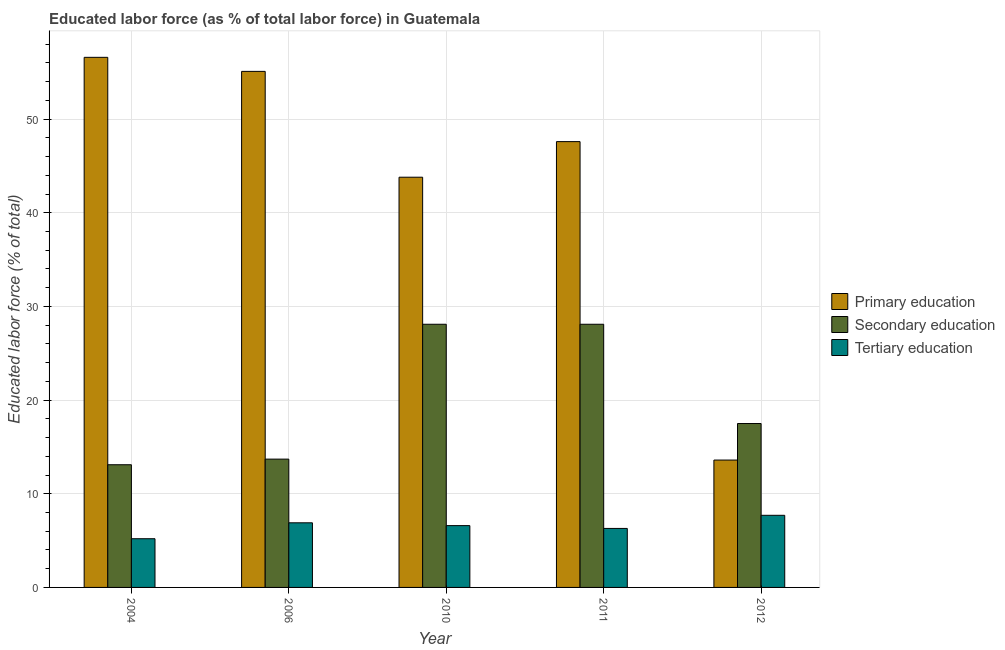Are the number of bars per tick equal to the number of legend labels?
Keep it short and to the point. Yes. Are the number of bars on each tick of the X-axis equal?
Keep it short and to the point. Yes. In how many cases, is the number of bars for a given year not equal to the number of legend labels?
Your response must be concise. 0. What is the percentage of labor force who received primary education in 2010?
Offer a very short reply. 43.8. Across all years, what is the maximum percentage of labor force who received tertiary education?
Keep it short and to the point. 7.7. Across all years, what is the minimum percentage of labor force who received primary education?
Your response must be concise. 13.6. In which year was the percentage of labor force who received tertiary education minimum?
Provide a succinct answer. 2004. What is the total percentage of labor force who received tertiary education in the graph?
Offer a terse response. 32.7. What is the difference between the percentage of labor force who received secondary education in 2006 and that in 2011?
Provide a short and direct response. -14.4. What is the difference between the percentage of labor force who received secondary education in 2011 and the percentage of labor force who received primary education in 2012?
Your answer should be very brief. 10.6. What is the average percentage of labor force who received secondary education per year?
Your answer should be very brief. 20.1. In the year 2004, what is the difference between the percentage of labor force who received secondary education and percentage of labor force who received tertiary education?
Your answer should be very brief. 0. In how many years, is the percentage of labor force who received secondary education greater than 20 %?
Offer a terse response. 2. What is the ratio of the percentage of labor force who received primary education in 2006 to that in 2010?
Offer a terse response. 1.26. What is the difference between the highest and the lowest percentage of labor force who received secondary education?
Ensure brevity in your answer.  15. Is the sum of the percentage of labor force who received primary education in 2004 and 2011 greater than the maximum percentage of labor force who received secondary education across all years?
Ensure brevity in your answer.  Yes. What does the 1st bar from the left in 2006 represents?
Keep it short and to the point. Primary education. What does the 2nd bar from the right in 2004 represents?
Offer a very short reply. Secondary education. Is it the case that in every year, the sum of the percentage of labor force who received primary education and percentage of labor force who received secondary education is greater than the percentage of labor force who received tertiary education?
Your response must be concise. Yes. Does the graph contain grids?
Offer a very short reply. Yes. Where does the legend appear in the graph?
Your answer should be compact. Center right. How many legend labels are there?
Offer a very short reply. 3. How are the legend labels stacked?
Your response must be concise. Vertical. What is the title of the graph?
Provide a short and direct response. Educated labor force (as % of total labor force) in Guatemala. What is the label or title of the Y-axis?
Provide a short and direct response. Educated labor force (% of total). What is the Educated labor force (% of total) in Primary education in 2004?
Your answer should be compact. 56.6. What is the Educated labor force (% of total) in Secondary education in 2004?
Offer a very short reply. 13.1. What is the Educated labor force (% of total) in Tertiary education in 2004?
Provide a short and direct response. 5.2. What is the Educated labor force (% of total) in Primary education in 2006?
Ensure brevity in your answer.  55.1. What is the Educated labor force (% of total) of Secondary education in 2006?
Make the answer very short. 13.7. What is the Educated labor force (% of total) of Tertiary education in 2006?
Make the answer very short. 6.9. What is the Educated labor force (% of total) in Primary education in 2010?
Ensure brevity in your answer.  43.8. What is the Educated labor force (% of total) of Secondary education in 2010?
Give a very brief answer. 28.1. What is the Educated labor force (% of total) in Tertiary education in 2010?
Offer a terse response. 6.6. What is the Educated labor force (% of total) of Primary education in 2011?
Make the answer very short. 47.6. What is the Educated labor force (% of total) in Secondary education in 2011?
Your response must be concise. 28.1. What is the Educated labor force (% of total) of Tertiary education in 2011?
Your answer should be compact. 6.3. What is the Educated labor force (% of total) in Primary education in 2012?
Make the answer very short. 13.6. What is the Educated labor force (% of total) of Secondary education in 2012?
Offer a terse response. 17.5. What is the Educated labor force (% of total) in Tertiary education in 2012?
Provide a succinct answer. 7.7. Across all years, what is the maximum Educated labor force (% of total) of Primary education?
Provide a short and direct response. 56.6. Across all years, what is the maximum Educated labor force (% of total) in Secondary education?
Keep it short and to the point. 28.1. Across all years, what is the maximum Educated labor force (% of total) in Tertiary education?
Provide a succinct answer. 7.7. Across all years, what is the minimum Educated labor force (% of total) of Primary education?
Offer a very short reply. 13.6. Across all years, what is the minimum Educated labor force (% of total) of Secondary education?
Provide a succinct answer. 13.1. Across all years, what is the minimum Educated labor force (% of total) in Tertiary education?
Your response must be concise. 5.2. What is the total Educated labor force (% of total) of Primary education in the graph?
Make the answer very short. 216.7. What is the total Educated labor force (% of total) of Secondary education in the graph?
Offer a very short reply. 100.5. What is the total Educated labor force (% of total) in Tertiary education in the graph?
Provide a succinct answer. 32.7. What is the difference between the Educated labor force (% of total) of Primary education in 2004 and that in 2006?
Your answer should be very brief. 1.5. What is the difference between the Educated labor force (% of total) of Secondary education in 2004 and that in 2010?
Make the answer very short. -15. What is the difference between the Educated labor force (% of total) in Tertiary education in 2004 and that in 2010?
Provide a short and direct response. -1.4. What is the difference between the Educated labor force (% of total) of Primary education in 2004 and that in 2011?
Offer a terse response. 9. What is the difference between the Educated labor force (% of total) in Secondary education in 2004 and that in 2011?
Your answer should be very brief. -15. What is the difference between the Educated labor force (% of total) in Tertiary education in 2004 and that in 2011?
Provide a short and direct response. -1.1. What is the difference between the Educated labor force (% of total) in Secondary education in 2004 and that in 2012?
Provide a short and direct response. -4.4. What is the difference between the Educated labor force (% of total) of Tertiary education in 2004 and that in 2012?
Keep it short and to the point. -2.5. What is the difference between the Educated labor force (% of total) of Secondary education in 2006 and that in 2010?
Keep it short and to the point. -14.4. What is the difference between the Educated labor force (% of total) of Tertiary education in 2006 and that in 2010?
Provide a succinct answer. 0.3. What is the difference between the Educated labor force (% of total) of Secondary education in 2006 and that in 2011?
Provide a short and direct response. -14.4. What is the difference between the Educated labor force (% of total) of Primary education in 2006 and that in 2012?
Ensure brevity in your answer.  41.5. What is the difference between the Educated labor force (% of total) of Secondary education in 2006 and that in 2012?
Your answer should be very brief. -3.8. What is the difference between the Educated labor force (% of total) in Tertiary education in 2006 and that in 2012?
Keep it short and to the point. -0.8. What is the difference between the Educated labor force (% of total) in Primary education in 2010 and that in 2011?
Offer a very short reply. -3.8. What is the difference between the Educated labor force (% of total) in Secondary education in 2010 and that in 2011?
Offer a very short reply. 0. What is the difference between the Educated labor force (% of total) of Primary education in 2010 and that in 2012?
Keep it short and to the point. 30.2. What is the difference between the Educated labor force (% of total) in Secondary education in 2010 and that in 2012?
Give a very brief answer. 10.6. What is the difference between the Educated labor force (% of total) in Tertiary education in 2010 and that in 2012?
Offer a very short reply. -1.1. What is the difference between the Educated labor force (% of total) of Tertiary education in 2011 and that in 2012?
Your answer should be compact. -1.4. What is the difference between the Educated labor force (% of total) in Primary education in 2004 and the Educated labor force (% of total) in Secondary education in 2006?
Your answer should be compact. 42.9. What is the difference between the Educated labor force (% of total) of Primary education in 2004 and the Educated labor force (% of total) of Tertiary education in 2006?
Provide a short and direct response. 49.7. What is the difference between the Educated labor force (% of total) of Secondary education in 2004 and the Educated labor force (% of total) of Tertiary education in 2006?
Your response must be concise. 6.2. What is the difference between the Educated labor force (% of total) of Primary education in 2004 and the Educated labor force (% of total) of Tertiary education in 2010?
Your answer should be very brief. 50. What is the difference between the Educated labor force (% of total) of Primary education in 2004 and the Educated labor force (% of total) of Tertiary education in 2011?
Your response must be concise. 50.3. What is the difference between the Educated labor force (% of total) in Primary education in 2004 and the Educated labor force (% of total) in Secondary education in 2012?
Provide a succinct answer. 39.1. What is the difference between the Educated labor force (% of total) in Primary education in 2004 and the Educated labor force (% of total) in Tertiary education in 2012?
Ensure brevity in your answer.  48.9. What is the difference between the Educated labor force (% of total) in Secondary education in 2004 and the Educated labor force (% of total) in Tertiary education in 2012?
Make the answer very short. 5.4. What is the difference between the Educated labor force (% of total) of Primary education in 2006 and the Educated labor force (% of total) of Secondary education in 2010?
Ensure brevity in your answer.  27. What is the difference between the Educated labor force (% of total) in Primary education in 2006 and the Educated labor force (% of total) in Tertiary education in 2010?
Your response must be concise. 48.5. What is the difference between the Educated labor force (% of total) in Secondary education in 2006 and the Educated labor force (% of total) in Tertiary education in 2010?
Offer a terse response. 7.1. What is the difference between the Educated labor force (% of total) in Primary education in 2006 and the Educated labor force (% of total) in Secondary education in 2011?
Provide a short and direct response. 27. What is the difference between the Educated labor force (% of total) in Primary education in 2006 and the Educated labor force (% of total) in Tertiary education in 2011?
Offer a very short reply. 48.8. What is the difference between the Educated labor force (% of total) of Secondary education in 2006 and the Educated labor force (% of total) of Tertiary education in 2011?
Keep it short and to the point. 7.4. What is the difference between the Educated labor force (% of total) in Primary education in 2006 and the Educated labor force (% of total) in Secondary education in 2012?
Make the answer very short. 37.6. What is the difference between the Educated labor force (% of total) of Primary education in 2006 and the Educated labor force (% of total) of Tertiary education in 2012?
Provide a short and direct response. 47.4. What is the difference between the Educated labor force (% of total) of Secondary education in 2006 and the Educated labor force (% of total) of Tertiary education in 2012?
Provide a short and direct response. 6. What is the difference between the Educated labor force (% of total) in Primary education in 2010 and the Educated labor force (% of total) in Tertiary education in 2011?
Keep it short and to the point. 37.5. What is the difference between the Educated labor force (% of total) in Secondary education in 2010 and the Educated labor force (% of total) in Tertiary education in 2011?
Your answer should be compact. 21.8. What is the difference between the Educated labor force (% of total) in Primary education in 2010 and the Educated labor force (% of total) in Secondary education in 2012?
Offer a terse response. 26.3. What is the difference between the Educated labor force (% of total) in Primary education in 2010 and the Educated labor force (% of total) in Tertiary education in 2012?
Offer a terse response. 36.1. What is the difference between the Educated labor force (% of total) in Secondary education in 2010 and the Educated labor force (% of total) in Tertiary education in 2012?
Your response must be concise. 20.4. What is the difference between the Educated labor force (% of total) in Primary education in 2011 and the Educated labor force (% of total) in Secondary education in 2012?
Ensure brevity in your answer.  30.1. What is the difference between the Educated labor force (% of total) in Primary education in 2011 and the Educated labor force (% of total) in Tertiary education in 2012?
Your response must be concise. 39.9. What is the difference between the Educated labor force (% of total) of Secondary education in 2011 and the Educated labor force (% of total) of Tertiary education in 2012?
Your answer should be very brief. 20.4. What is the average Educated labor force (% of total) of Primary education per year?
Give a very brief answer. 43.34. What is the average Educated labor force (% of total) in Secondary education per year?
Give a very brief answer. 20.1. What is the average Educated labor force (% of total) in Tertiary education per year?
Make the answer very short. 6.54. In the year 2004, what is the difference between the Educated labor force (% of total) in Primary education and Educated labor force (% of total) in Secondary education?
Ensure brevity in your answer.  43.5. In the year 2004, what is the difference between the Educated labor force (% of total) of Primary education and Educated labor force (% of total) of Tertiary education?
Keep it short and to the point. 51.4. In the year 2006, what is the difference between the Educated labor force (% of total) in Primary education and Educated labor force (% of total) in Secondary education?
Offer a very short reply. 41.4. In the year 2006, what is the difference between the Educated labor force (% of total) in Primary education and Educated labor force (% of total) in Tertiary education?
Give a very brief answer. 48.2. In the year 2006, what is the difference between the Educated labor force (% of total) of Secondary education and Educated labor force (% of total) of Tertiary education?
Your answer should be very brief. 6.8. In the year 2010, what is the difference between the Educated labor force (% of total) in Primary education and Educated labor force (% of total) in Tertiary education?
Give a very brief answer. 37.2. In the year 2010, what is the difference between the Educated labor force (% of total) of Secondary education and Educated labor force (% of total) of Tertiary education?
Make the answer very short. 21.5. In the year 2011, what is the difference between the Educated labor force (% of total) of Primary education and Educated labor force (% of total) of Tertiary education?
Offer a terse response. 41.3. In the year 2011, what is the difference between the Educated labor force (% of total) of Secondary education and Educated labor force (% of total) of Tertiary education?
Offer a terse response. 21.8. In the year 2012, what is the difference between the Educated labor force (% of total) of Primary education and Educated labor force (% of total) of Secondary education?
Offer a terse response. -3.9. In the year 2012, what is the difference between the Educated labor force (% of total) in Primary education and Educated labor force (% of total) in Tertiary education?
Keep it short and to the point. 5.9. What is the ratio of the Educated labor force (% of total) of Primary education in 2004 to that in 2006?
Your response must be concise. 1.03. What is the ratio of the Educated labor force (% of total) of Secondary education in 2004 to that in 2006?
Give a very brief answer. 0.96. What is the ratio of the Educated labor force (% of total) in Tertiary education in 2004 to that in 2006?
Give a very brief answer. 0.75. What is the ratio of the Educated labor force (% of total) in Primary education in 2004 to that in 2010?
Your answer should be very brief. 1.29. What is the ratio of the Educated labor force (% of total) of Secondary education in 2004 to that in 2010?
Keep it short and to the point. 0.47. What is the ratio of the Educated labor force (% of total) of Tertiary education in 2004 to that in 2010?
Give a very brief answer. 0.79. What is the ratio of the Educated labor force (% of total) of Primary education in 2004 to that in 2011?
Offer a very short reply. 1.19. What is the ratio of the Educated labor force (% of total) in Secondary education in 2004 to that in 2011?
Your answer should be compact. 0.47. What is the ratio of the Educated labor force (% of total) in Tertiary education in 2004 to that in 2011?
Provide a short and direct response. 0.83. What is the ratio of the Educated labor force (% of total) of Primary education in 2004 to that in 2012?
Keep it short and to the point. 4.16. What is the ratio of the Educated labor force (% of total) of Secondary education in 2004 to that in 2012?
Ensure brevity in your answer.  0.75. What is the ratio of the Educated labor force (% of total) of Tertiary education in 2004 to that in 2012?
Ensure brevity in your answer.  0.68. What is the ratio of the Educated labor force (% of total) of Primary education in 2006 to that in 2010?
Your answer should be compact. 1.26. What is the ratio of the Educated labor force (% of total) in Secondary education in 2006 to that in 2010?
Make the answer very short. 0.49. What is the ratio of the Educated labor force (% of total) of Tertiary education in 2006 to that in 2010?
Ensure brevity in your answer.  1.05. What is the ratio of the Educated labor force (% of total) of Primary education in 2006 to that in 2011?
Offer a very short reply. 1.16. What is the ratio of the Educated labor force (% of total) in Secondary education in 2006 to that in 2011?
Provide a short and direct response. 0.49. What is the ratio of the Educated labor force (% of total) of Tertiary education in 2006 to that in 2011?
Give a very brief answer. 1.1. What is the ratio of the Educated labor force (% of total) of Primary education in 2006 to that in 2012?
Provide a succinct answer. 4.05. What is the ratio of the Educated labor force (% of total) in Secondary education in 2006 to that in 2012?
Give a very brief answer. 0.78. What is the ratio of the Educated labor force (% of total) in Tertiary education in 2006 to that in 2012?
Your response must be concise. 0.9. What is the ratio of the Educated labor force (% of total) of Primary education in 2010 to that in 2011?
Your answer should be very brief. 0.92. What is the ratio of the Educated labor force (% of total) in Secondary education in 2010 to that in 2011?
Offer a terse response. 1. What is the ratio of the Educated labor force (% of total) of Tertiary education in 2010 to that in 2011?
Provide a succinct answer. 1.05. What is the ratio of the Educated labor force (% of total) in Primary education in 2010 to that in 2012?
Make the answer very short. 3.22. What is the ratio of the Educated labor force (% of total) of Secondary education in 2010 to that in 2012?
Keep it short and to the point. 1.61. What is the ratio of the Educated labor force (% of total) of Secondary education in 2011 to that in 2012?
Your response must be concise. 1.61. What is the ratio of the Educated labor force (% of total) in Tertiary education in 2011 to that in 2012?
Your response must be concise. 0.82. What is the difference between the highest and the second highest Educated labor force (% of total) in Primary education?
Provide a short and direct response. 1.5. What is the difference between the highest and the second highest Educated labor force (% of total) in Secondary education?
Offer a very short reply. 0. What is the difference between the highest and the second highest Educated labor force (% of total) in Tertiary education?
Make the answer very short. 0.8. What is the difference between the highest and the lowest Educated labor force (% of total) of Tertiary education?
Keep it short and to the point. 2.5. 